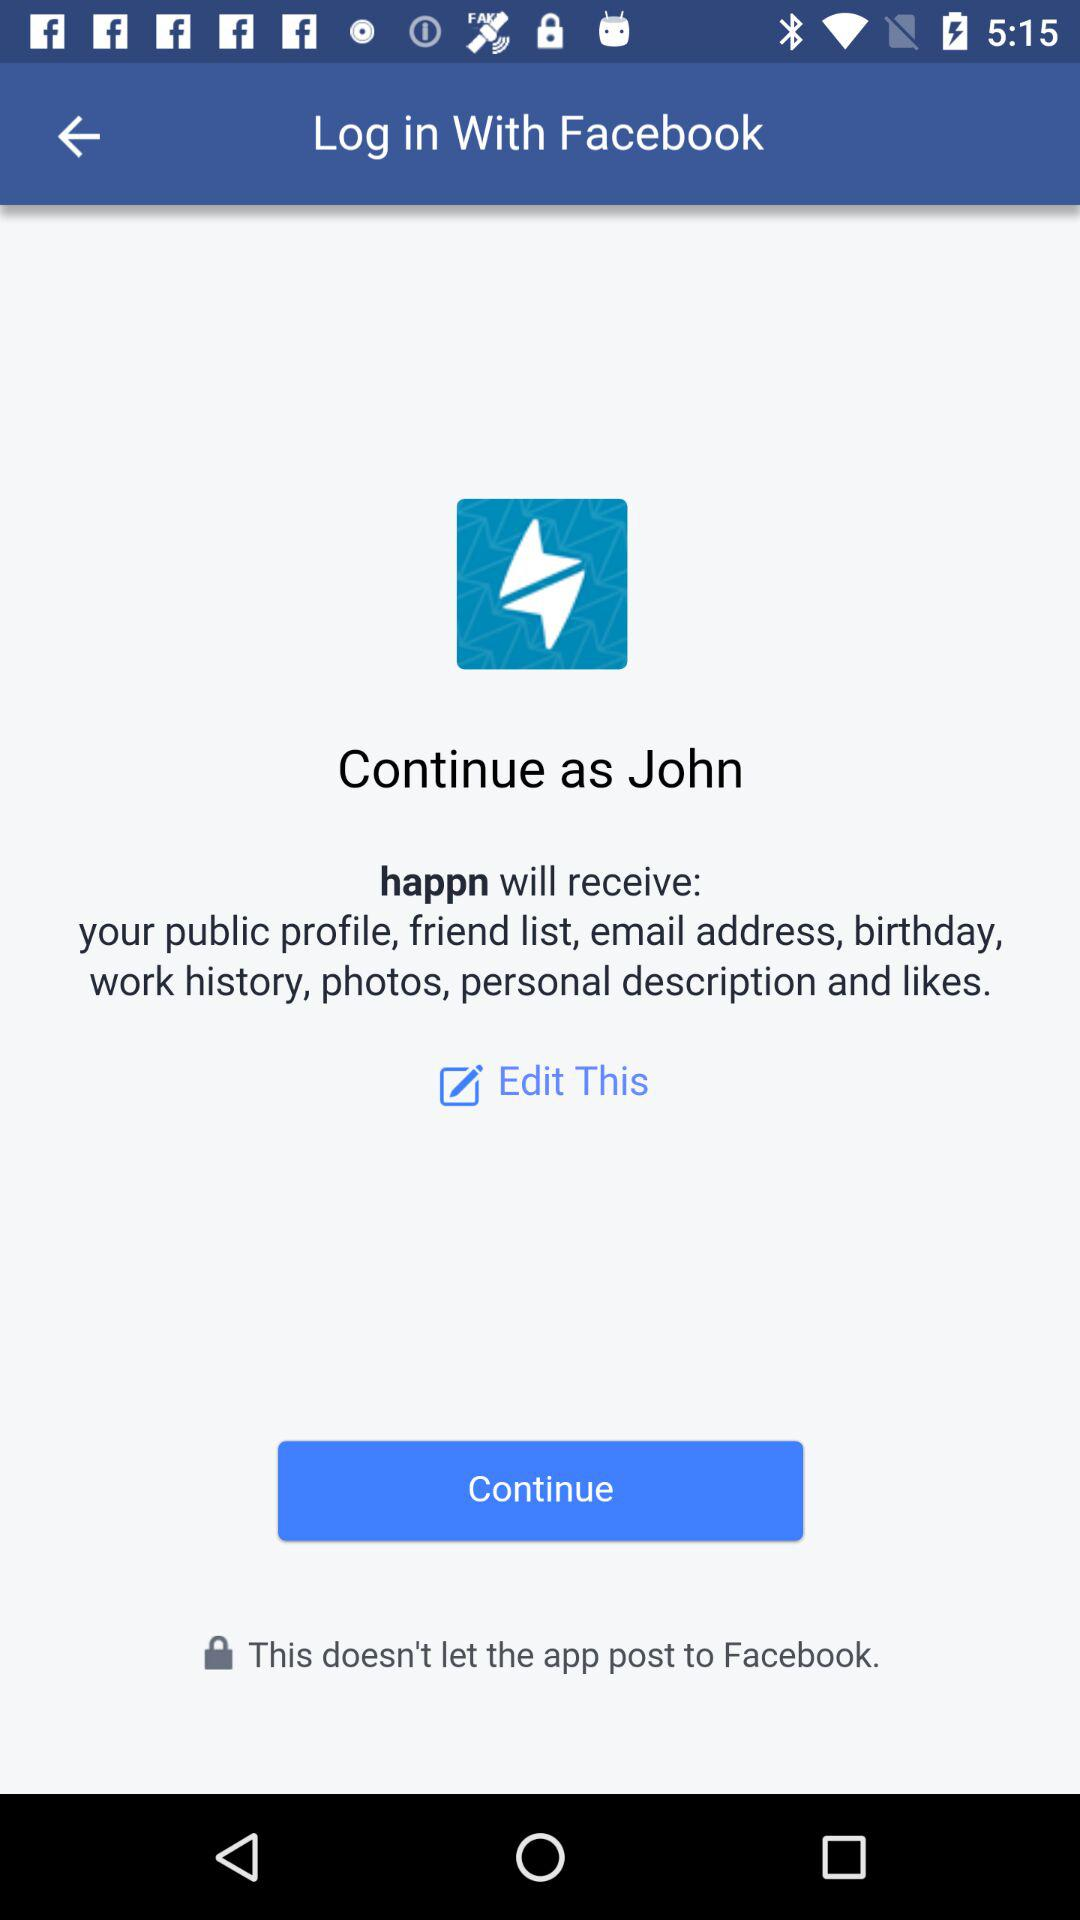Which app receives your email address and birthday? The app is "happn". 